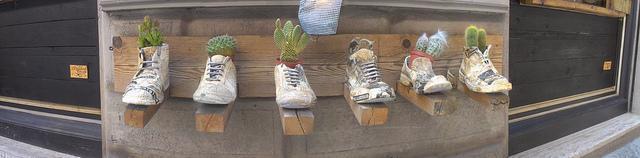Which shoes require watering more than daily?
Select the accurate answer and provide explanation: 'Answer: answer
Rationale: rationale.'
Options: Right ones, none, all, left ones. Answer: none.
Rationale: Cacti don't generally need to be watered daily. 